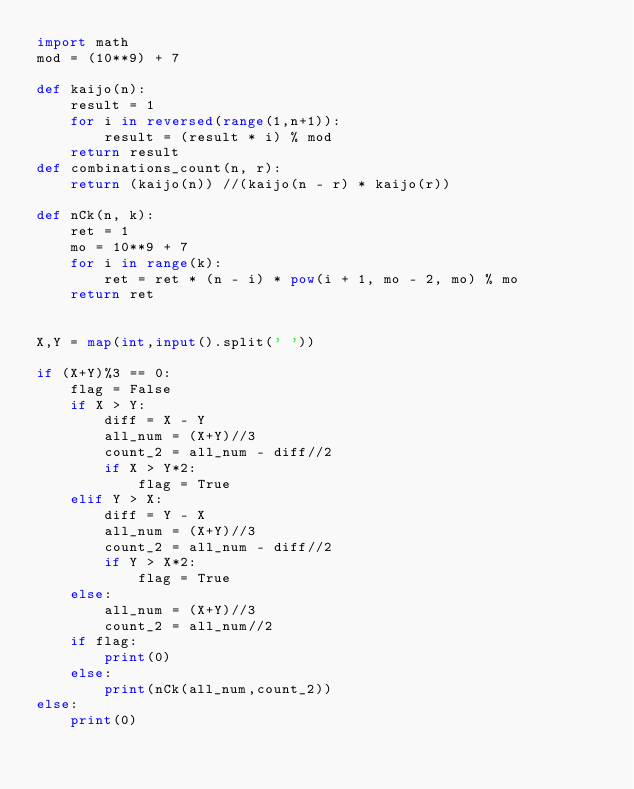<code> <loc_0><loc_0><loc_500><loc_500><_Python_>import math
mod = (10**9) + 7

def kaijo(n):
    result = 1
    for i in reversed(range(1,n+1)):
        result = (result * i) % mod
    return result
def combinations_count(n, r):
    return (kaijo(n)) //(kaijo(n - r) * kaijo(r))

def nCk(n, k):
    ret = 1
    mo = 10**9 + 7
    for i in range(k):
        ret = ret * (n - i) * pow(i + 1, mo - 2, mo) % mo
    return ret


X,Y = map(int,input().split(' '))

if (X+Y)%3 == 0:
    flag = False
    if X > Y:
        diff = X - Y
        all_num = (X+Y)//3
        count_2 = all_num - diff//2
        if X > Y*2:
            flag = True
    elif Y > X:
        diff = Y - X
        all_num = (X+Y)//3
        count_2 = all_num - diff//2
        if Y > X*2:
            flag = True
    else:
        all_num = (X+Y)//3
        count_2 = all_num//2
    if flag:
        print(0)
    else:
        print(nCk(all_num,count_2))
else:
    print(0)
</code> 